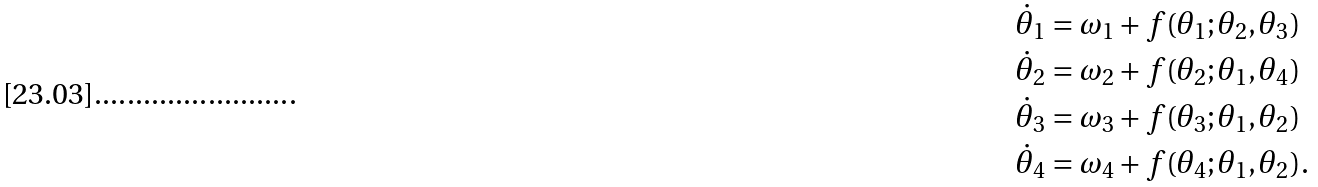Convert formula to latex. <formula><loc_0><loc_0><loc_500><loc_500>\dot { \theta } _ { 1 } & = \omega _ { 1 } + f ( \theta _ { 1 } ; \theta _ { 2 } , \theta _ { 3 } ) \\ \dot { \theta } _ { 2 } & = \omega _ { 2 } + f ( \theta _ { 2 } ; \theta _ { 1 } , \theta _ { 4 } ) \\ \dot { \theta } _ { 3 } & = \omega _ { 3 } + f ( \theta _ { 3 } ; \theta _ { 1 } , \theta _ { 2 } ) \\ \dot { \theta } _ { 4 } & = \omega _ { 4 } + f ( \theta _ { 4 } ; \theta _ { 1 } , \theta _ { 2 } ) .</formula> 